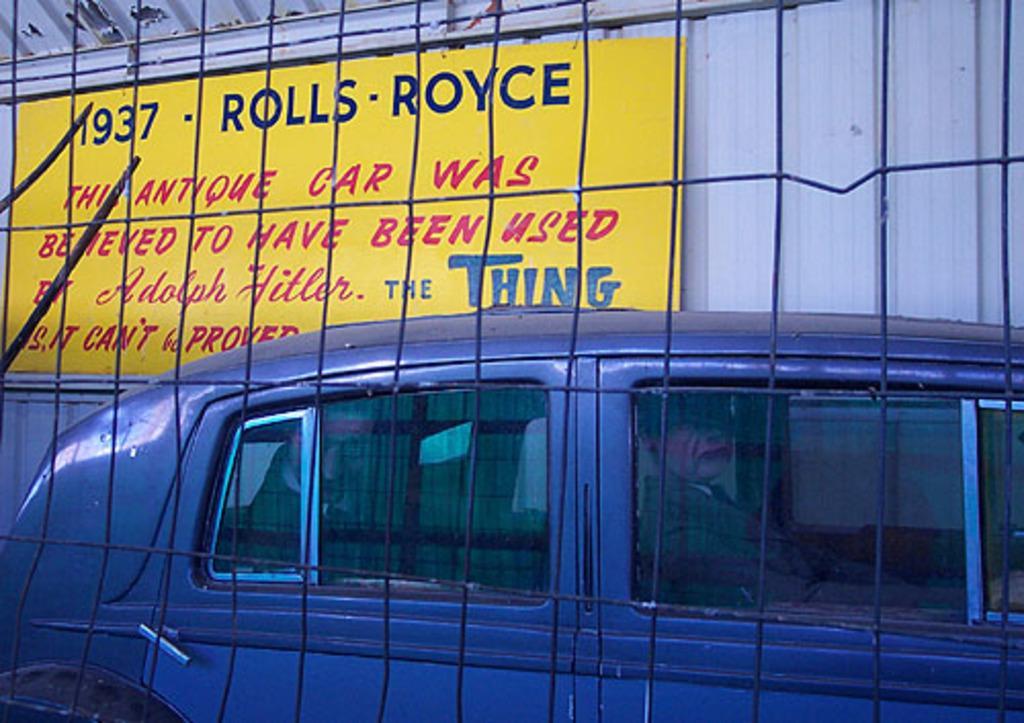In one or two sentences, can you explain what this image depicts? In this image we can see a vehicle. In the background there is a board and a shed. In the foreground we can see a mesh. 